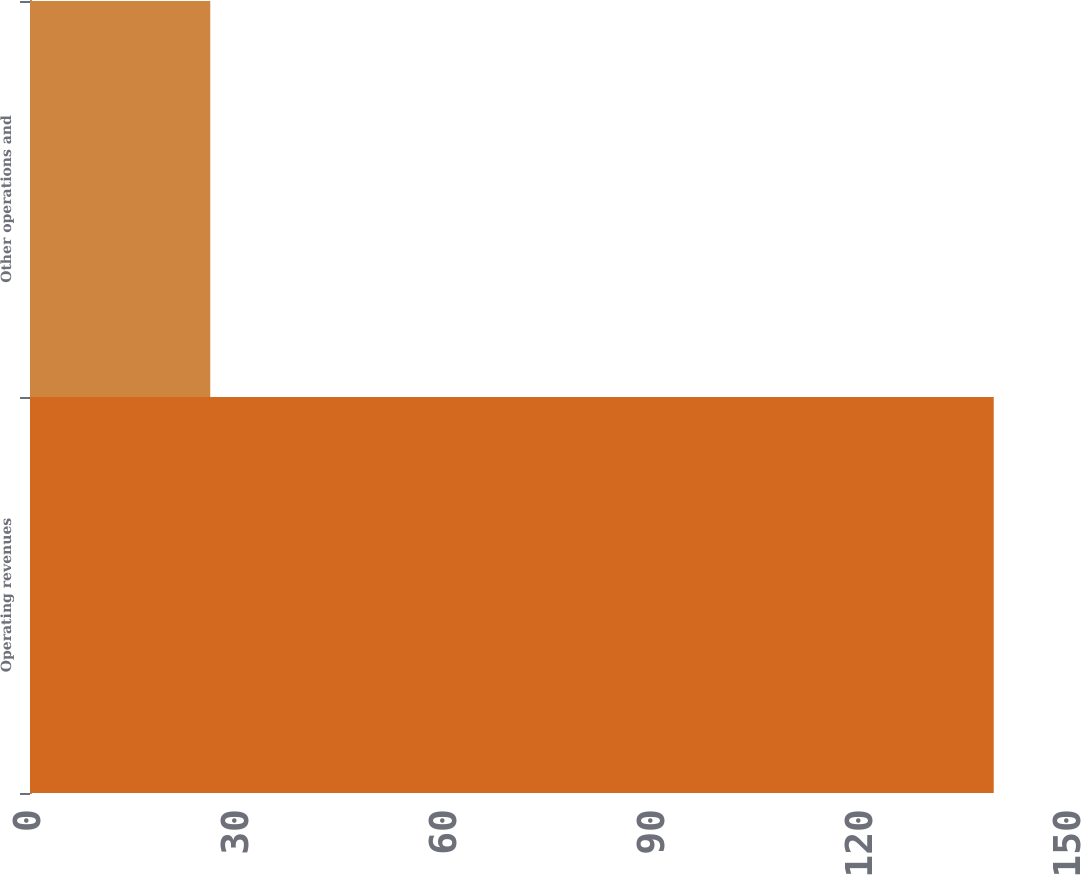<chart> <loc_0><loc_0><loc_500><loc_500><bar_chart><fcel>Operating revenues<fcel>Other operations and<nl><fcel>139<fcel>26<nl></chart> 